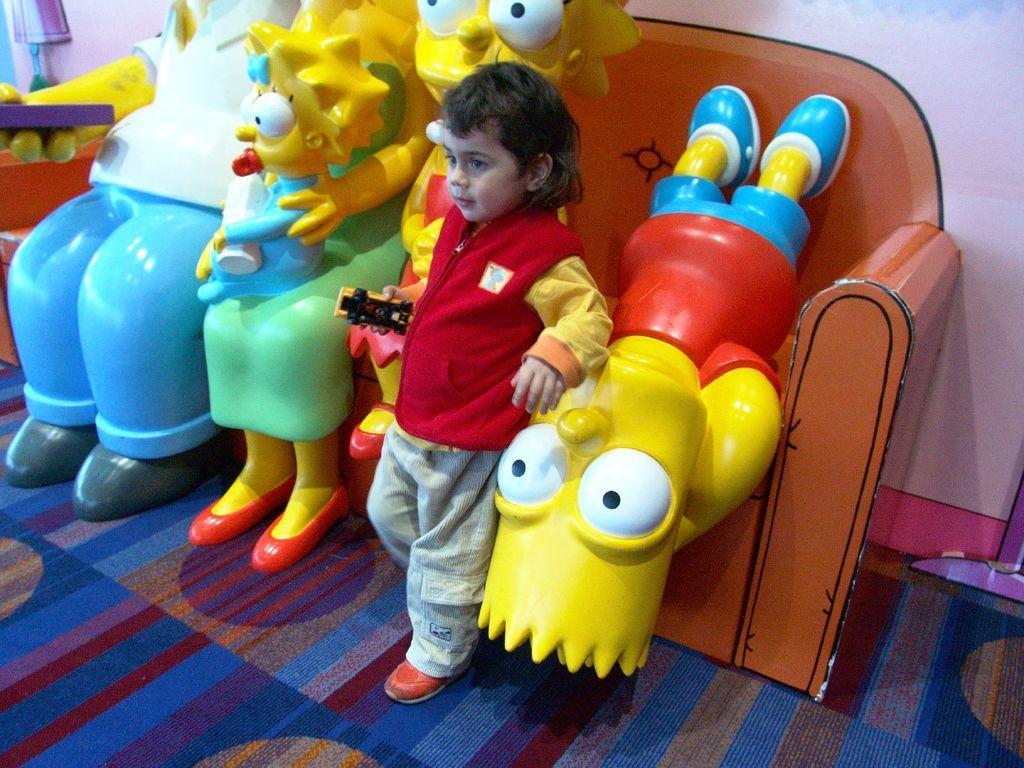Please provide a concise description of this image. In this image there is a boy standing near toys on a floor. 